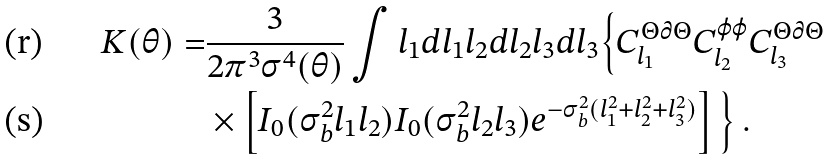Convert formula to latex. <formula><loc_0><loc_0><loc_500><loc_500>K ( \theta ) = & \frac { 3 } { 2 \pi ^ { 3 } \sigma ^ { 4 } ( \theta ) } \int l _ { 1 } d l _ { 1 } l _ { 2 } d l _ { 2 } l _ { 3 } d l _ { 3 } \Big { \{ } C _ { l _ { 1 } } ^ { \Theta \partial \Theta } C _ { l _ { 2 } } ^ { \varphi \varphi } C _ { l _ { 3 } } ^ { \Theta \partial \Theta } \\ & \times \left [ I _ { 0 } ( \sigma _ { b } ^ { 2 } l _ { 1 } l _ { 2 } ) I _ { 0 } ( \sigma _ { b } ^ { 2 } l _ { 2 } l _ { 3 } ) e ^ { - \sigma _ { b } ^ { 2 } ( l _ { 1 } ^ { 2 } + l _ { 2 } ^ { 2 } + l _ { 3 } ^ { 2 } ) } \right ] \Big { \} } \, .</formula> 